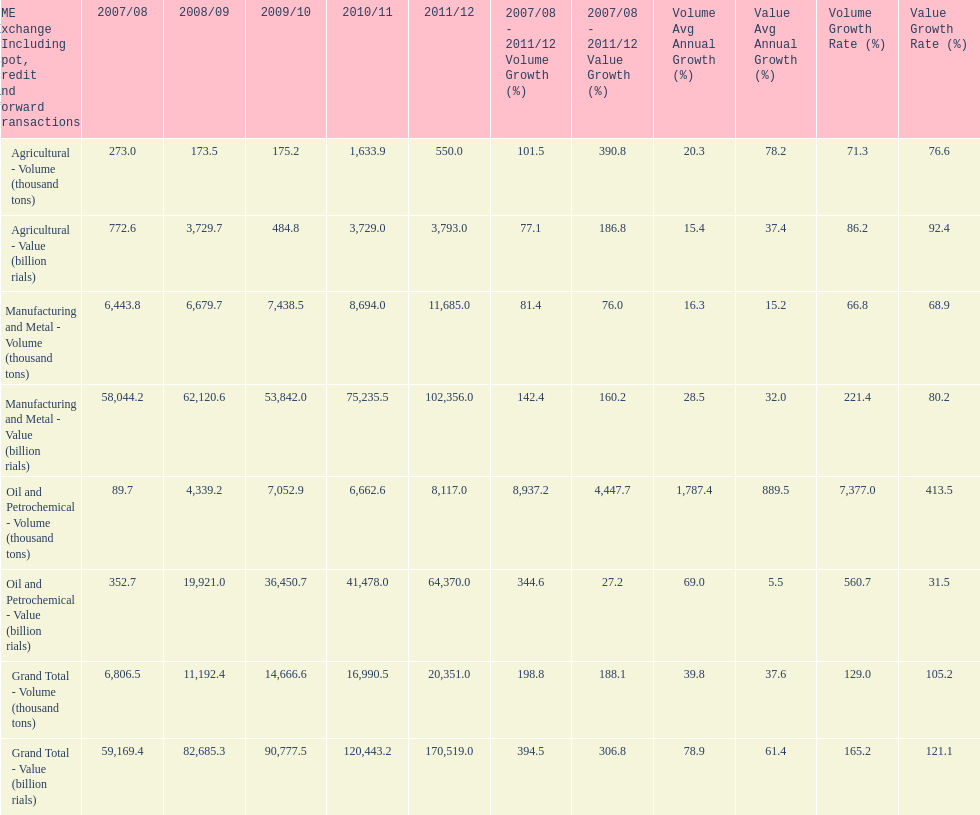Which year had the largest agricultural volume? 2010/11. 